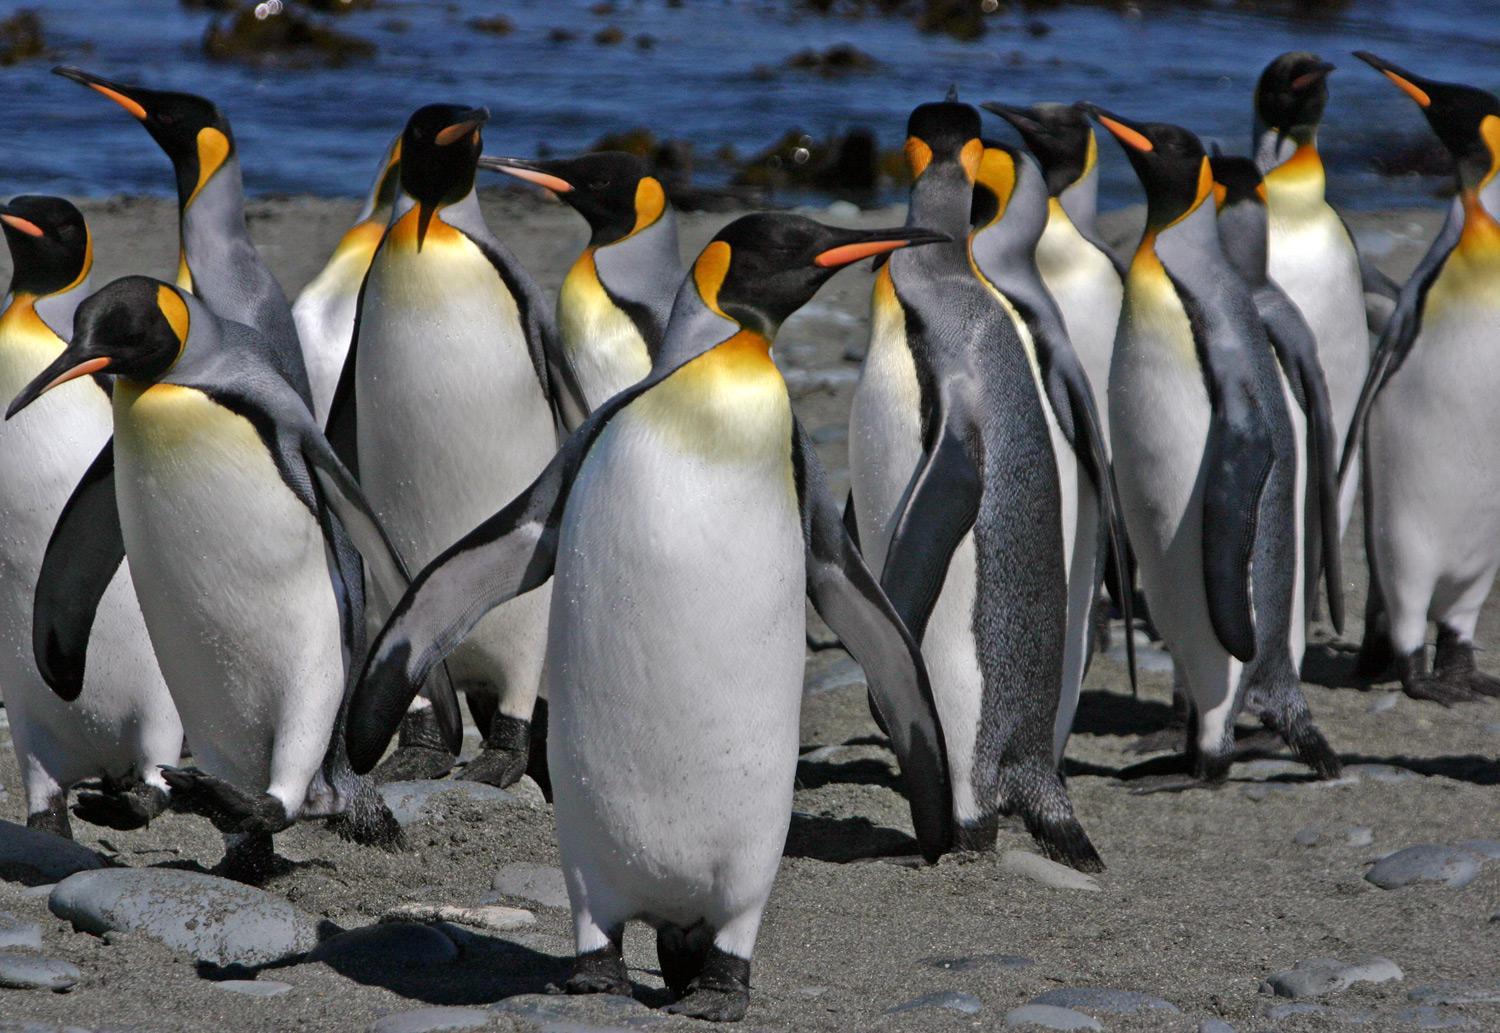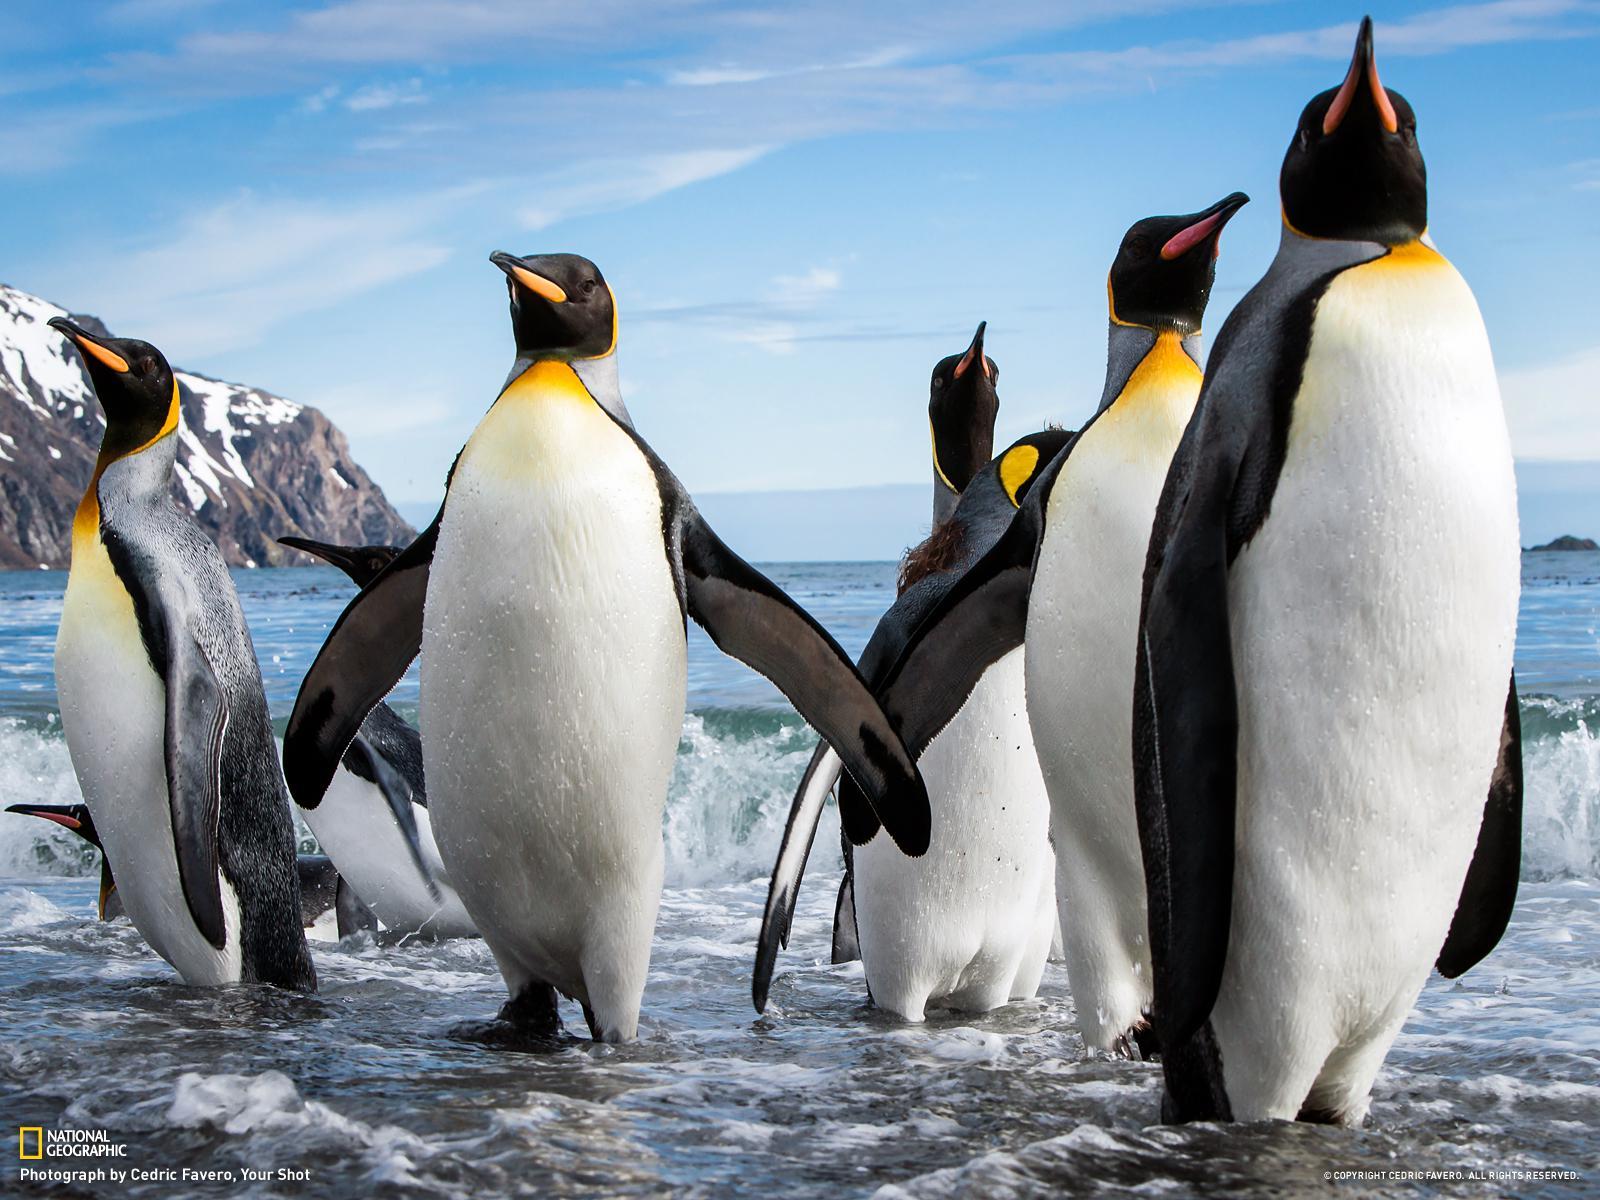The first image is the image on the left, the second image is the image on the right. Evaluate the accuracy of this statement regarding the images: "An image contains just two penguins.". Is it true? Answer yes or no. No. The first image is the image on the left, the second image is the image on the right. For the images displayed, is the sentence "There are two penguins in the left image." factually correct? Answer yes or no. No. The first image is the image on the left, the second image is the image on the right. Given the left and right images, does the statement "There are only two penguins in at least one of the images." hold true? Answer yes or no. No. The first image is the image on the left, the second image is the image on the right. Considering the images on both sides, is "Two penguins stand near each other in the picture on the left." valid? Answer yes or no. No. The first image is the image on the left, the second image is the image on the right. For the images shown, is this caption "There are four penguins" true? Answer yes or no. No. The first image is the image on the left, the second image is the image on the right. Evaluate the accuracy of this statement regarding the images: "An image features two penguins standing close together.". Is it true? Answer yes or no. No. 